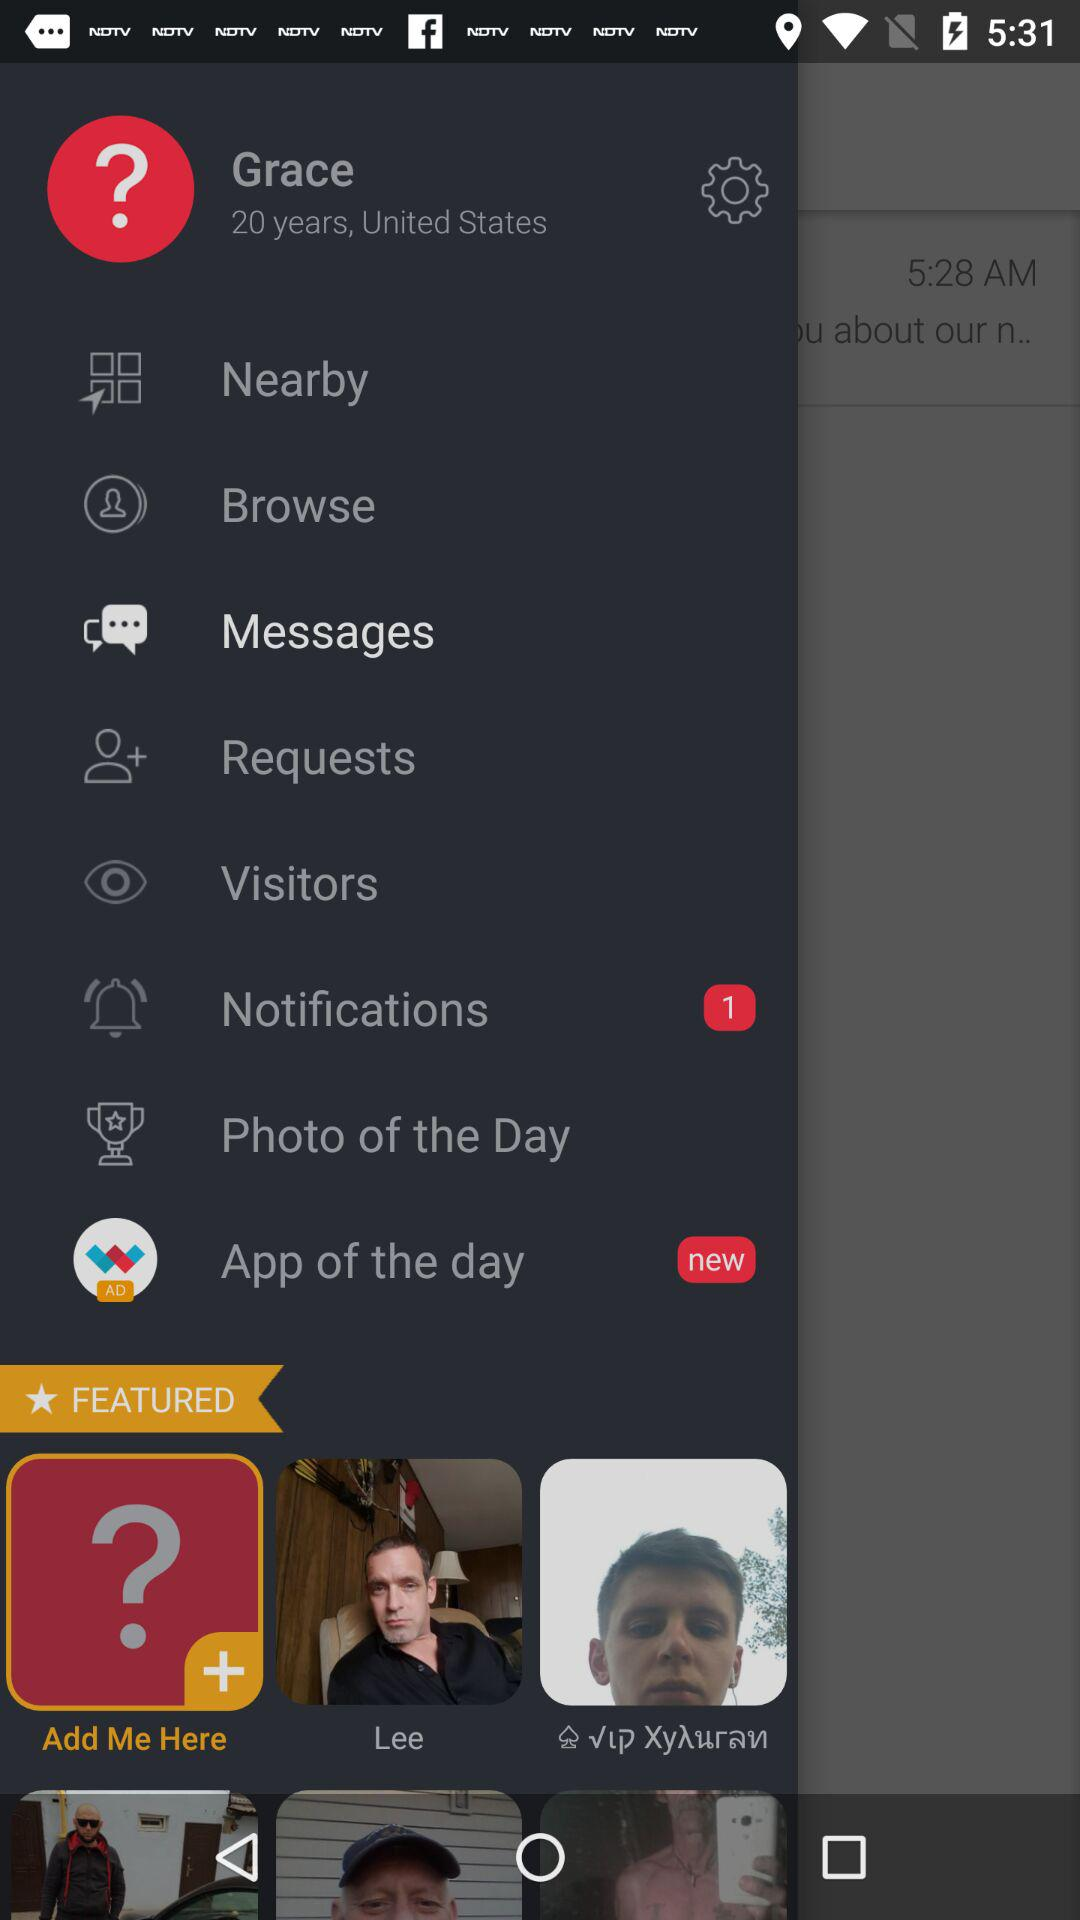How many unread notifications are there? There is 1 unread notification. 